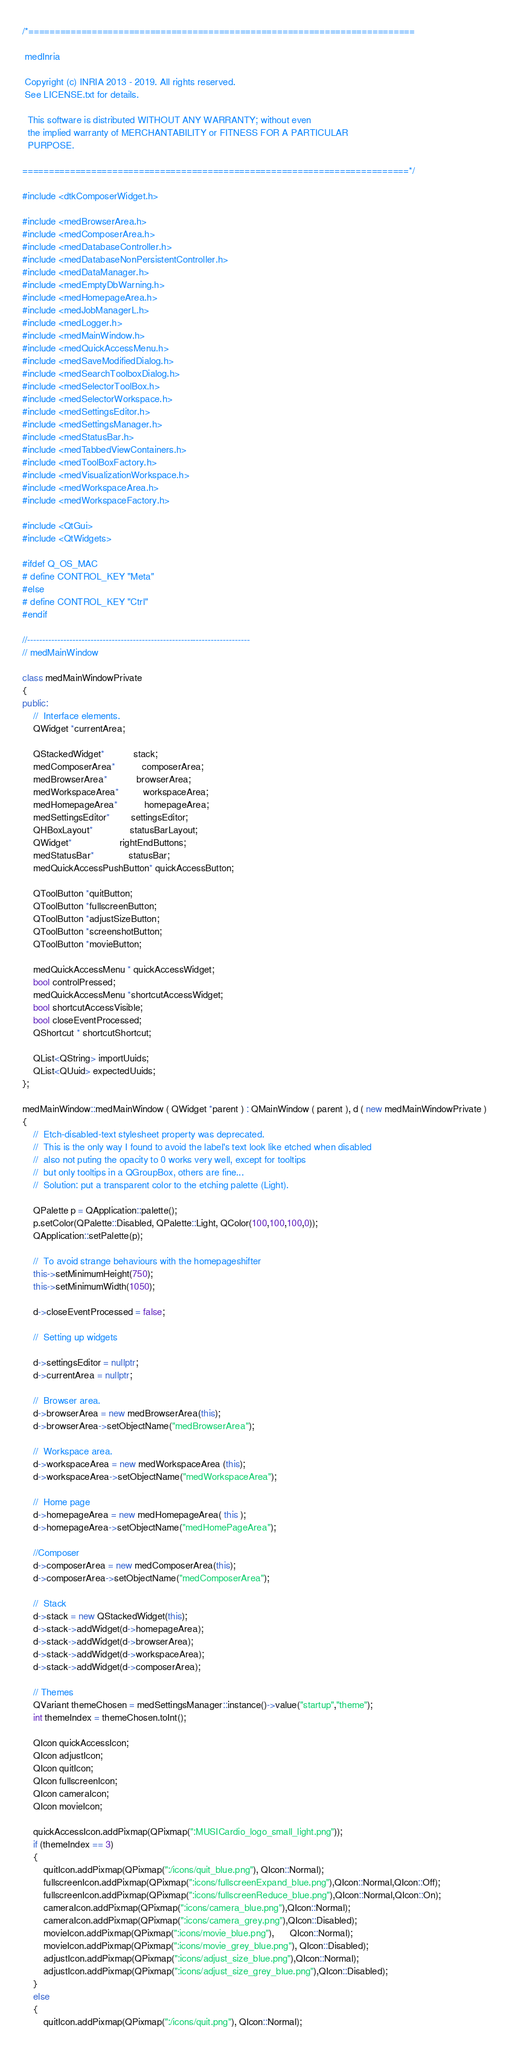Convert code to text. <code><loc_0><loc_0><loc_500><loc_500><_C++_>/*=========================================================================

 medInria

 Copyright (c) INRIA 2013 - 2019. All rights reserved.
 See LICENSE.txt for details.

  This software is distributed WITHOUT ANY WARRANTY; without even
  the implied warranty of MERCHANTABILITY or FITNESS FOR A PARTICULAR
  PURPOSE.

=========================================================================*/

#include <dtkComposerWidget.h>

#include <medBrowserArea.h>
#include <medComposerArea.h>
#include <medDatabaseController.h>
#include <medDatabaseNonPersistentController.h>
#include <medDataManager.h>
#include <medEmptyDbWarning.h>
#include <medHomepageArea.h>
#include <medJobManagerL.h>
#include <medLogger.h>
#include <medMainWindow.h>
#include <medQuickAccessMenu.h>
#include <medSaveModifiedDialog.h>
#include <medSearchToolboxDialog.h>
#include <medSelectorToolBox.h>
#include <medSelectorWorkspace.h>
#include <medSettingsEditor.h>
#include <medSettingsManager.h>
#include <medStatusBar.h>
#include <medTabbedViewContainers.h>
#include <medToolBoxFactory.h>
#include <medVisualizationWorkspace.h>
#include <medWorkspaceArea.h>
#include <medWorkspaceFactory.h>

#include <QtGui>
#include <QtWidgets>

#ifdef Q_OS_MAC
# define CONTROL_KEY "Meta"
#else
# define CONTROL_KEY "Ctrl"
#endif

//--------------------------------------------------------------------------
// medMainWindow

class medMainWindowPrivate
{
public:
    //  Interface elements.
    QWidget *currentArea;

    QStackedWidget*           stack;
    medComposerArea*          composerArea;
    medBrowserArea*           browserArea;
    medWorkspaceArea*         workspaceArea;
    medHomepageArea*          homepageArea;
    medSettingsEditor*        settingsEditor;
    QHBoxLayout*              statusBarLayout;
    QWidget*                  rightEndButtons;
    medStatusBar*             statusBar;
    medQuickAccessPushButton* quickAccessButton;
    
    QToolButton *quitButton;
    QToolButton *fullscreenButton;
    QToolButton *adjustSizeButton;
    QToolButton *screenshotButton;
    QToolButton *movieButton;
    
    medQuickAccessMenu * quickAccessWidget;
    bool controlPressed;
    medQuickAccessMenu *shortcutAccessWidget;
    bool shortcutAccessVisible;
    bool closeEventProcessed;
    QShortcut * shortcutShortcut;

    QList<QString> importUuids;
    QList<QUuid> expectedUuids;
};

medMainWindow::medMainWindow ( QWidget *parent ) : QMainWindow ( parent ), d ( new medMainWindowPrivate )
{
    //  Etch-disabled-text stylesheet property was deprecated.
    //  This is the only way I found to avoid the label's text look like etched when disabled
    //  also not puting the opacity to 0 works very well, except for tooltips
    //  but only tooltips in a QGroupBox, others are fine...
    //  Solution: put a transparent color to the etching palette (Light).

    QPalette p = QApplication::palette();
    p.setColor(QPalette::Disabled, QPalette::Light, QColor(100,100,100,0));
    QApplication::setPalette(p);

    //  To avoid strange behaviours with the homepageshifter
    this->setMinimumHeight(750);
    this->setMinimumWidth(1050);

    d->closeEventProcessed = false;

    //  Setting up widgets

    d->settingsEditor = nullptr;
    d->currentArea = nullptr;

    //  Browser area.
    d->browserArea = new medBrowserArea(this);
    d->browserArea->setObjectName("medBrowserArea");

    //  Workspace area.
    d->workspaceArea = new medWorkspaceArea (this);
    d->workspaceArea->setObjectName("medWorkspaceArea");

    //  Home page
    d->homepageArea = new medHomepageArea( this );
    d->homepageArea->setObjectName("medHomePageArea");

    //Composer
    d->composerArea = new medComposerArea(this);
    d->composerArea->setObjectName("medComposerArea");

    //  Stack
    d->stack = new QStackedWidget(this);
    d->stack->addWidget(d->homepageArea);
    d->stack->addWidget(d->browserArea);
    d->stack->addWidget(d->workspaceArea);
    d->stack->addWidget(d->composerArea);

    // Themes
    QVariant themeChosen = medSettingsManager::instance()->value("startup","theme");
    int themeIndex = themeChosen.toInt();

    QIcon quickAccessIcon;
    QIcon adjustIcon;
    QIcon quitIcon;
    QIcon fullscreenIcon;
    QIcon cameraIcon;
    QIcon movieIcon;

    quickAccessIcon.addPixmap(QPixmap(":MUSICardio_logo_small_light.png"));
    if (themeIndex == 3)
    {
        quitIcon.addPixmap(QPixmap(":/icons/quit_blue.png"), QIcon::Normal);
        fullscreenIcon.addPixmap(QPixmap(":icons/fullscreenExpand_blue.png"),QIcon::Normal,QIcon::Off);
        fullscreenIcon.addPixmap(QPixmap(":icons/fullscreenReduce_blue.png"),QIcon::Normal,QIcon::On);
        cameraIcon.addPixmap(QPixmap(":icons/camera_blue.png"),QIcon::Normal);
        cameraIcon.addPixmap(QPixmap(":icons/camera_grey.png"),QIcon::Disabled);
        movieIcon.addPixmap(QPixmap(":icons/movie_blue.png"),      QIcon::Normal);
        movieIcon.addPixmap(QPixmap(":icons/movie_grey_blue.png"), QIcon::Disabled);
        adjustIcon.addPixmap(QPixmap(":icons/adjust_size_blue.png"),QIcon::Normal);
        adjustIcon.addPixmap(QPixmap(":icons/adjust_size_grey_blue.png"),QIcon::Disabled);
    }
    else
    {
        quitIcon.addPixmap(QPixmap(":/icons/quit.png"), QIcon::Normal);</code> 